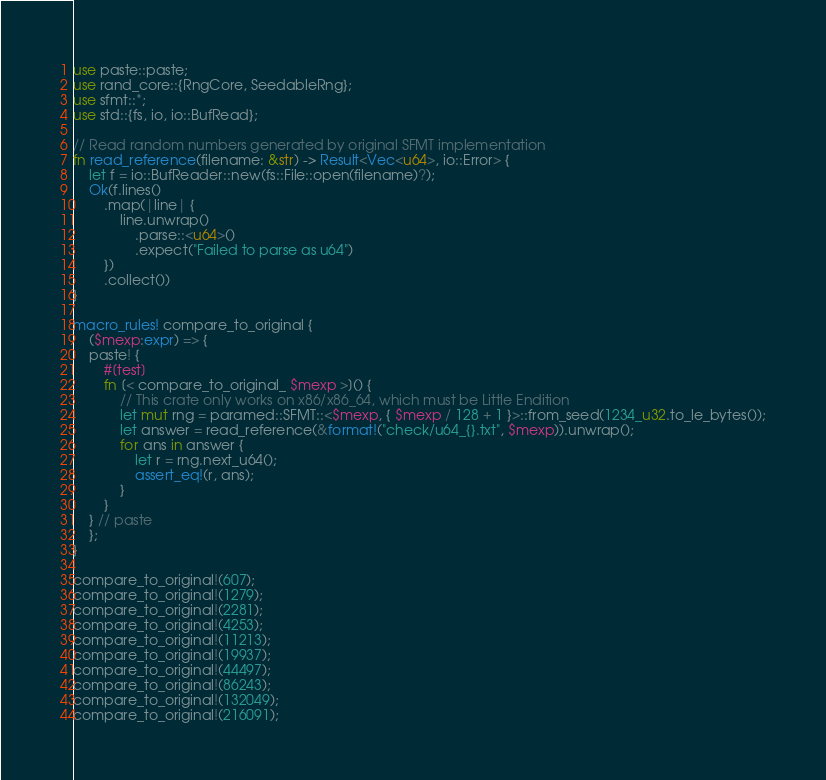Convert code to text. <code><loc_0><loc_0><loc_500><loc_500><_Rust_>use paste::paste;
use rand_core::{RngCore, SeedableRng};
use sfmt::*;
use std::{fs, io, io::BufRead};

// Read random numbers generated by original SFMT implementation
fn read_reference(filename: &str) -> Result<Vec<u64>, io::Error> {
    let f = io::BufReader::new(fs::File::open(filename)?);
    Ok(f.lines()
        .map(|line| {
            line.unwrap()
                .parse::<u64>()
                .expect("Failed to parse as u64")
        })
        .collect())
}

macro_rules! compare_to_original {
    ($mexp:expr) => {
    paste! {
        #[test]
        fn [< compare_to_original_ $mexp >]() {
            // This crate only works on x86/x86_64, which must be Little Endition
            let mut rng = paramed::SFMT::<$mexp, { $mexp / 128 + 1 }>::from_seed(1234_u32.to_le_bytes());
            let answer = read_reference(&format!("check/u64_{}.txt", $mexp)).unwrap();
            for ans in answer {
                let r = rng.next_u64();
                assert_eq!(r, ans);
            }
        }
    } // paste
    };
}

compare_to_original!(607);
compare_to_original!(1279);
compare_to_original!(2281);
compare_to_original!(4253);
compare_to_original!(11213);
compare_to_original!(19937);
compare_to_original!(44497);
compare_to_original!(86243);
compare_to_original!(132049);
compare_to_original!(216091);
</code> 